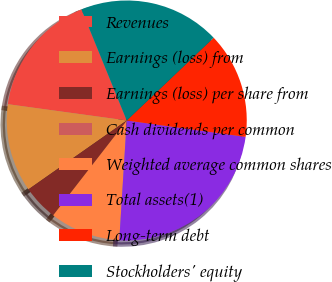Convert chart to OTSL. <chart><loc_0><loc_0><loc_500><loc_500><pie_chart><fcel>Revenues<fcel>Earnings (loss) from<fcel>Earnings (loss) per share from<fcel>Cash dividends per common<fcel>Weighted average common shares<fcel>Total assets(1)<fcel>Long-term debt<fcel>Stockholders' equity<nl><fcel>16.67%<fcel>11.9%<fcel>4.76%<fcel>0.0%<fcel>9.52%<fcel>23.81%<fcel>14.29%<fcel>19.05%<nl></chart> 